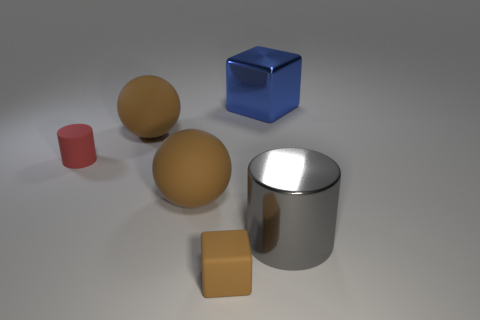Add 3 big green shiny blocks. How many objects exist? 9 Subtract all spheres. How many objects are left? 4 Subtract all tiny cylinders. Subtract all cylinders. How many objects are left? 3 Add 3 gray metallic cylinders. How many gray metallic cylinders are left? 4 Add 4 small brown matte things. How many small brown matte things exist? 5 Subtract 1 blue cubes. How many objects are left? 5 